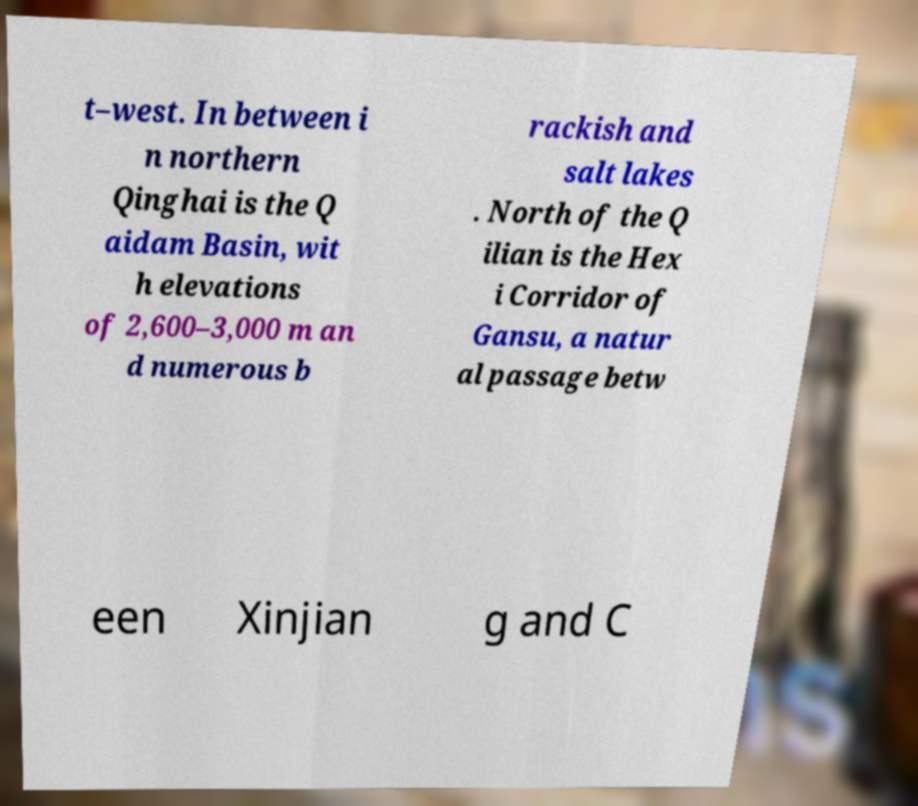Can you read and provide the text displayed in the image?This photo seems to have some interesting text. Can you extract and type it out for me? t–west. In between i n northern Qinghai is the Q aidam Basin, wit h elevations of 2,600–3,000 m an d numerous b rackish and salt lakes . North of the Q ilian is the Hex i Corridor of Gansu, a natur al passage betw een Xinjian g and C 